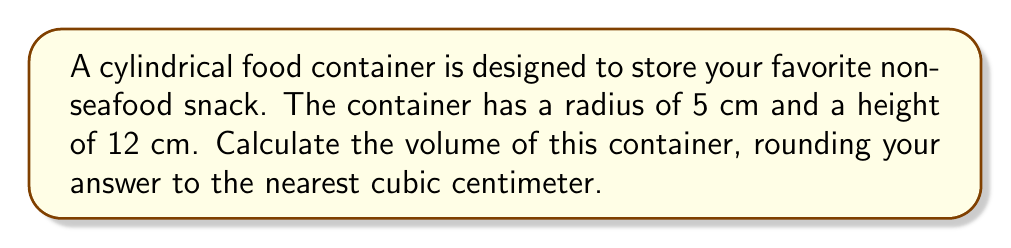Teach me how to tackle this problem. To calculate the volume of a cylindrical container, we use the formula:

$$V = \pi r^2 h$$

Where:
$V$ = volume
$\pi$ = pi (approximately 3.14159)
$r$ = radius of the base
$h$ = height of the cylinder

Given:
$r = 5$ cm
$h = 12$ cm

Let's substitute these values into the formula:

$$V = \pi (5\text{ cm})^2 (12\text{ cm})$$

First, calculate the square of the radius:
$$(5\text{ cm})^2 = 25\text{ cm}^2$$

Now, our equation looks like this:

$$V = \pi (25\text{ cm}^2) (12\text{ cm})$$

Multiply the values inside the parentheses:

$$V = \pi (300\text{ cm}^3)$$

Using 3.14159 as an approximation for $\pi$:

$$V \approx 3.14159 (300\text{ cm}^3)$$

$$V \approx 942.477\text{ cm}^3$$

Rounding to the nearest cubic centimeter:

$$V \approx 942\text{ cm}^3$$
Answer: $942\text{ cm}^3$ 